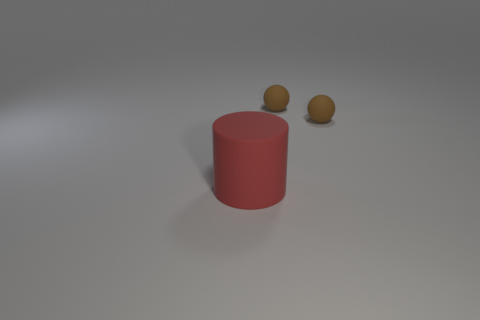Subtract all brown cylinders. Subtract all red blocks. How many cylinders are left? 1 Add 2 cylinders. How many objects exist? 5 Subtract all spheres. How many objects are left? 1 Add 2 large red rubber cylinders. How many large red rubber cylinders are left? 3 Add 2 large matte things. How many large matte things exist? 3 Subtract 0 brown cylinders. How many objects are left? 3 Subtract all brown objects. Subtract all big red matte objects. How many objects are left? 0 